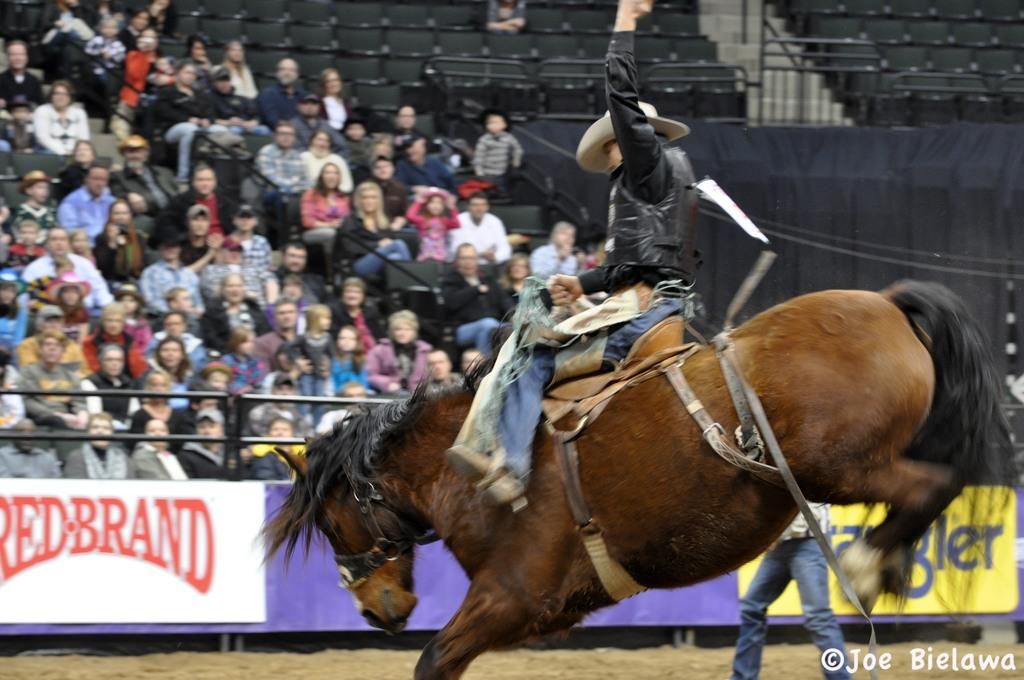What is the main subject of the image? The main subject of the image is a man. What is the man doing in the image? The man is sitting on a horse and trying to control it. What is the man wearing in the image? The man is wearing a hat. Are there any other people in the image? Yes, there are people watching in the image. What type of tin can be seen on the desk in the image? There is no tin or desk present in the image; it features a man sitting on a horse with people watching. 